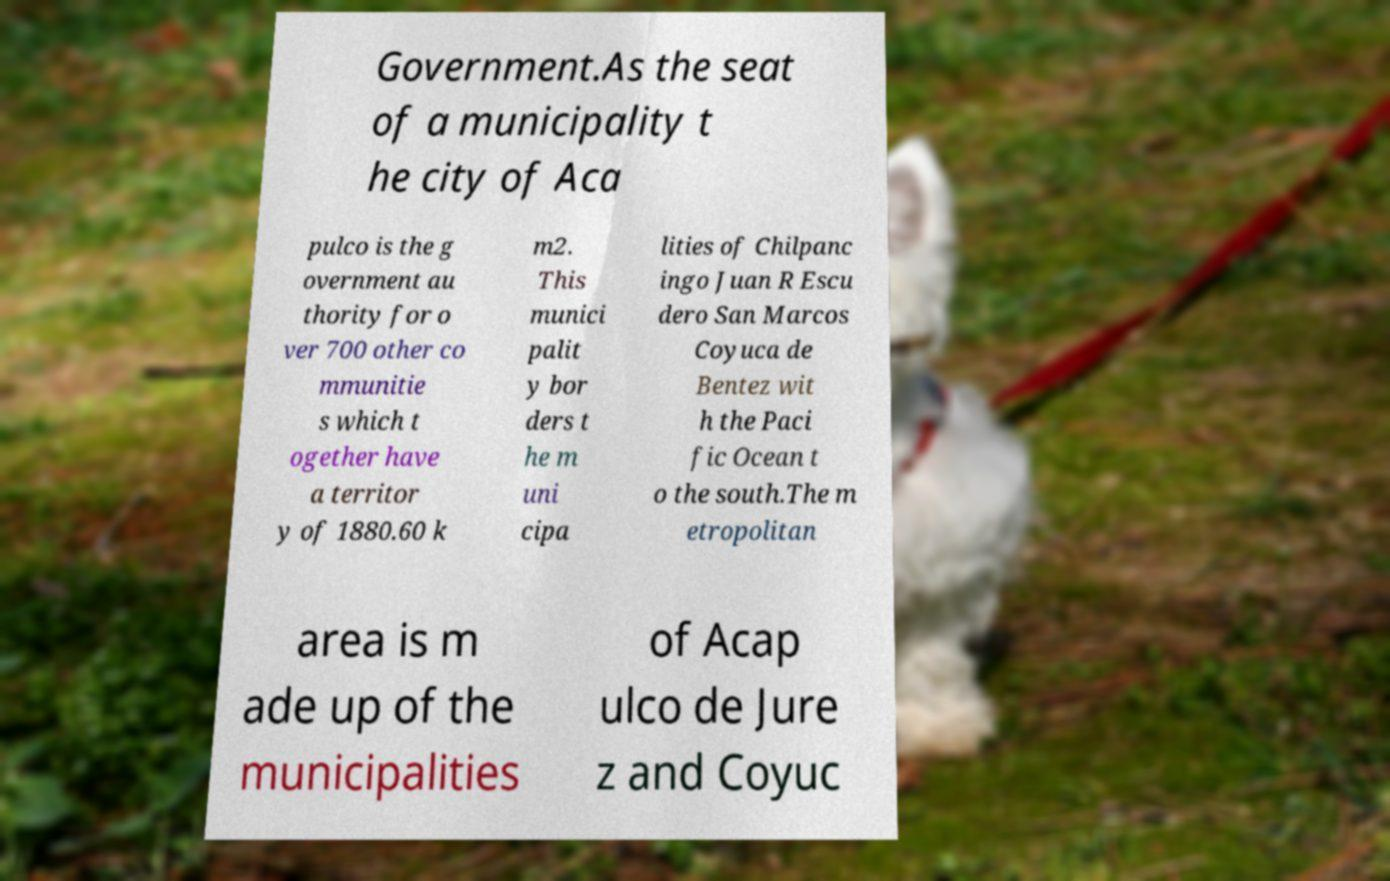Can you read and provide the text displayed in the image?This photo seems to have some interesting text. Can you extract and type it out for me? Government.As the seat of a municipality t he city of Aca pulco is the g overnment au thority for o ver 700 other co mmunitie s which t ogether have a territor y of 1880.60 k m2. This munici palit y bor ders t he m uni cipa lities of Chilpanc ingo Juan R Escu dero San Marcos Coyuca de Bentez wit h the Paci fic Ocean t o the south.The m etropolitan area is m ade up of the municipalities of Acap ulco de Jure z and Coyuc 